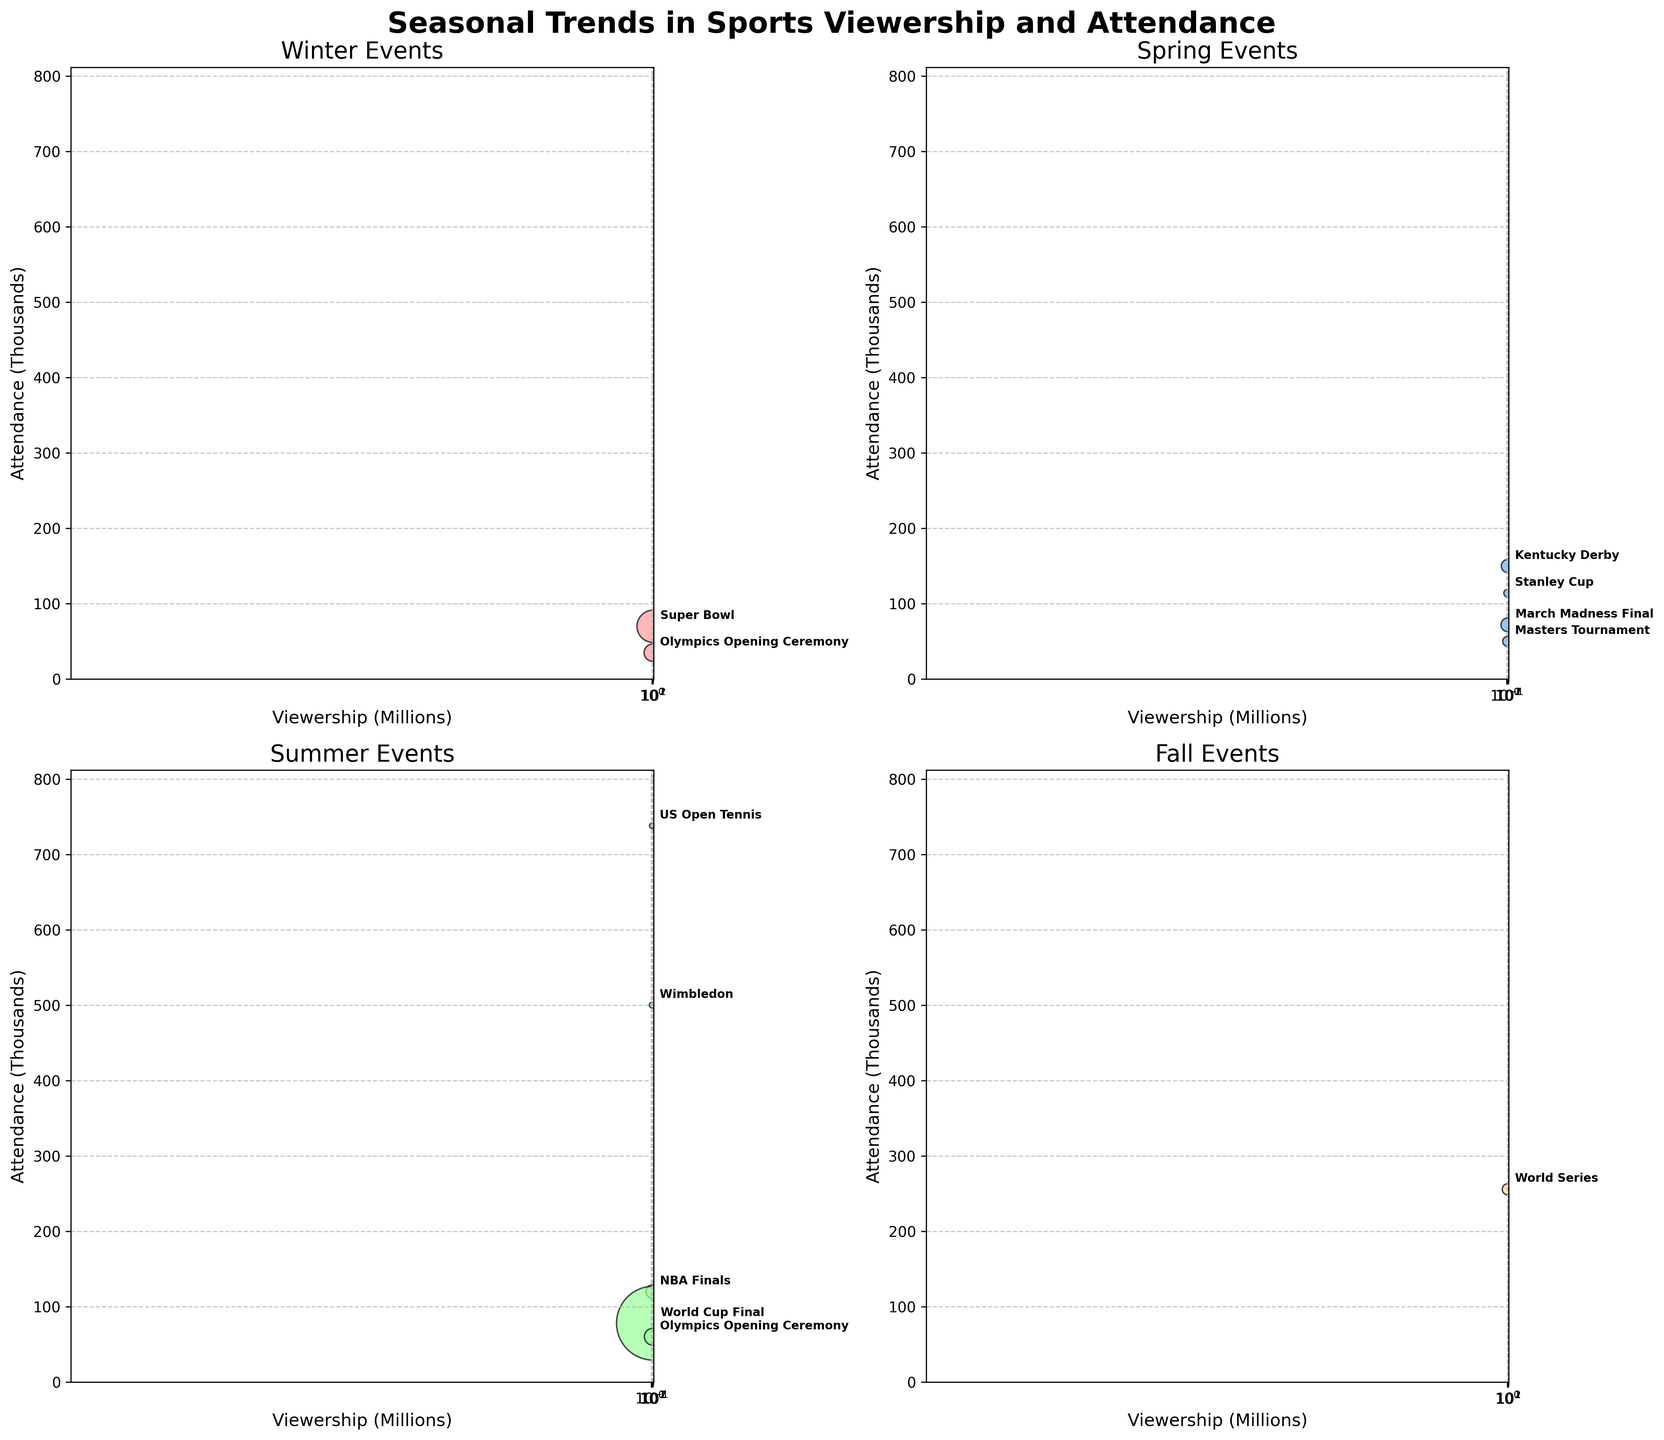What is the title of the figure? The title of the figure is usually located at the top and often gives a summary of what the figure is about. In this case, the title is "Seasonal Trends in Sports Viewership and Attendance," which is located at the top of the figure in bold font.
Answer: Seasonal Trends in Sports Viewership and Attendance How are the axes labeled in the figure? The axes labels provide information on what each axis represents. In all subplots, the x-axis is labeled "Viewership (Millions)" and the y-axis is labeled "Attendance (Thousands)."
Answer: Viewership (Millions), Attendance (Thousands) Which event has the highest viewership in the Summer season? To determine this, look at the Summer subplot and identify the point furthest to the right on the x-axis (Viewership). The World Cup Final has the highest viewership at 517.0 million.
Answer: World Cup Final What is the attendance for the Master's Tournament in the Spring season? Locate the Master's Tournament in the Spring subplot and look for its y-coordinate (Attendance). The attendance for the Master's Tournament is 50 thousand.
Answer: 50 thousand Which season has the most events displayed in the subplots? To find this, count the number of data points (events) in each subplot. Summer has the most events with 5 (NBA Finals, Wimbledon, World Cup Final, Olympics Opening Ceremony (Summer), US Open Tennis).
Answer: Summer Compare the viewership and attendance between the Super Bowl and March Madness Final. Locate the Super Bowl in the Winter subplot and the March Madness Final in the Spring subplot. The Super Bowl has higher viewership (98.2 million vs. 18.1 million) but lower attendance (70 thousand vs. 72 thousand).
Answer: Super Bowl has higher viewership but lower attendance What is the average attendance in the Fall season? The Fall season has only the World Series. The attendance, therefore, is also its average, which is 256 thousand.
Answer: 256 thousand Which event has the lowest viewership in the Summer season? Identify the point with the lowest x-coordinate (Viewership) in the Summer subplot. The US Open Tennis has the lowest viewership at 2.7 million.
Answer: US Open Tennis What is the total attendance for all events in the Winter season? Sum the attendance values for the events in the Winter subplot. The Super Bowl has 70 thousand, and the Winter Olympics Opening Ceremony has 35 thousand. The total attendance is 70 + 35 = 105 thousand.
Answer: 105 thousand Which season features the event with the largest attendance, and what is that event? To find this, compare the highest points on the y-axis across the subplots. Wimbledon (Summer) has the largest attendance at 500 thousand.
Answer: Summer, Wimbledon 